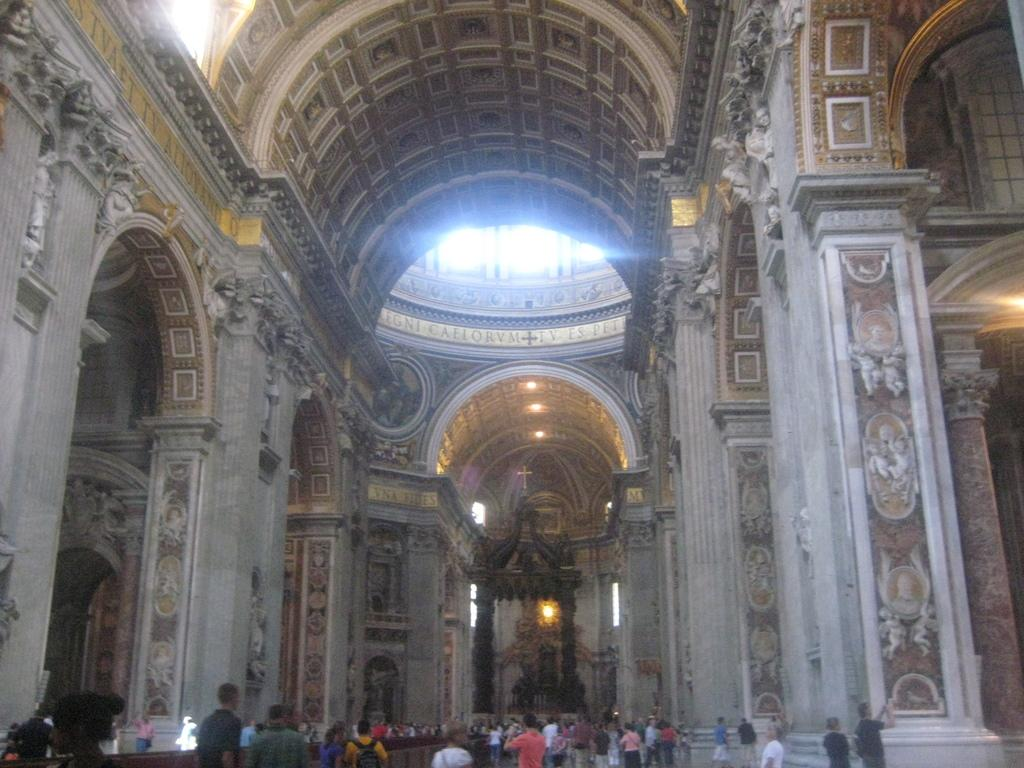What type of structure can be seen in the image? There is a wall in the image. Who or what is present in the image? There are people in the image. What can be seen illuminating the area in the image? There are lights in the image. What type of artwork is visible in the image? There are sculptures and a statue in the image. What type of flame can be seen coming from the statue in the image? There is no flame present in the image; the statue is not depicted as emitting any fire or heat. 